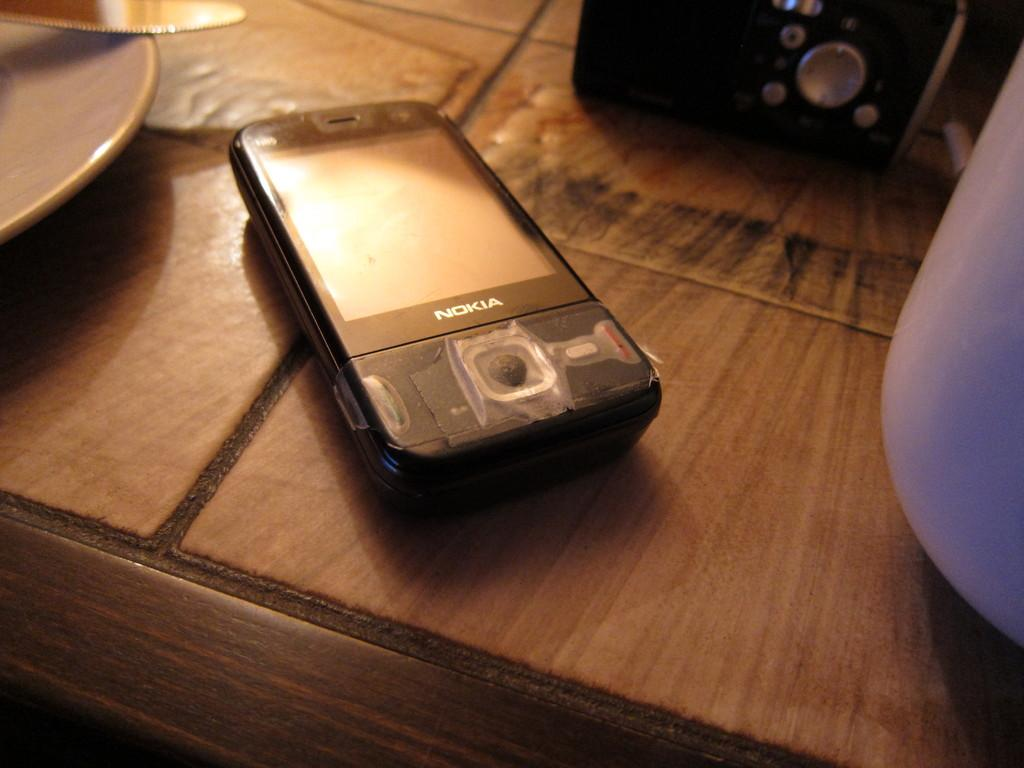<image>
Offer a succinct explanation of the picture presented. A Nokia phone with the plastic protection covering still on it sits on a table. 